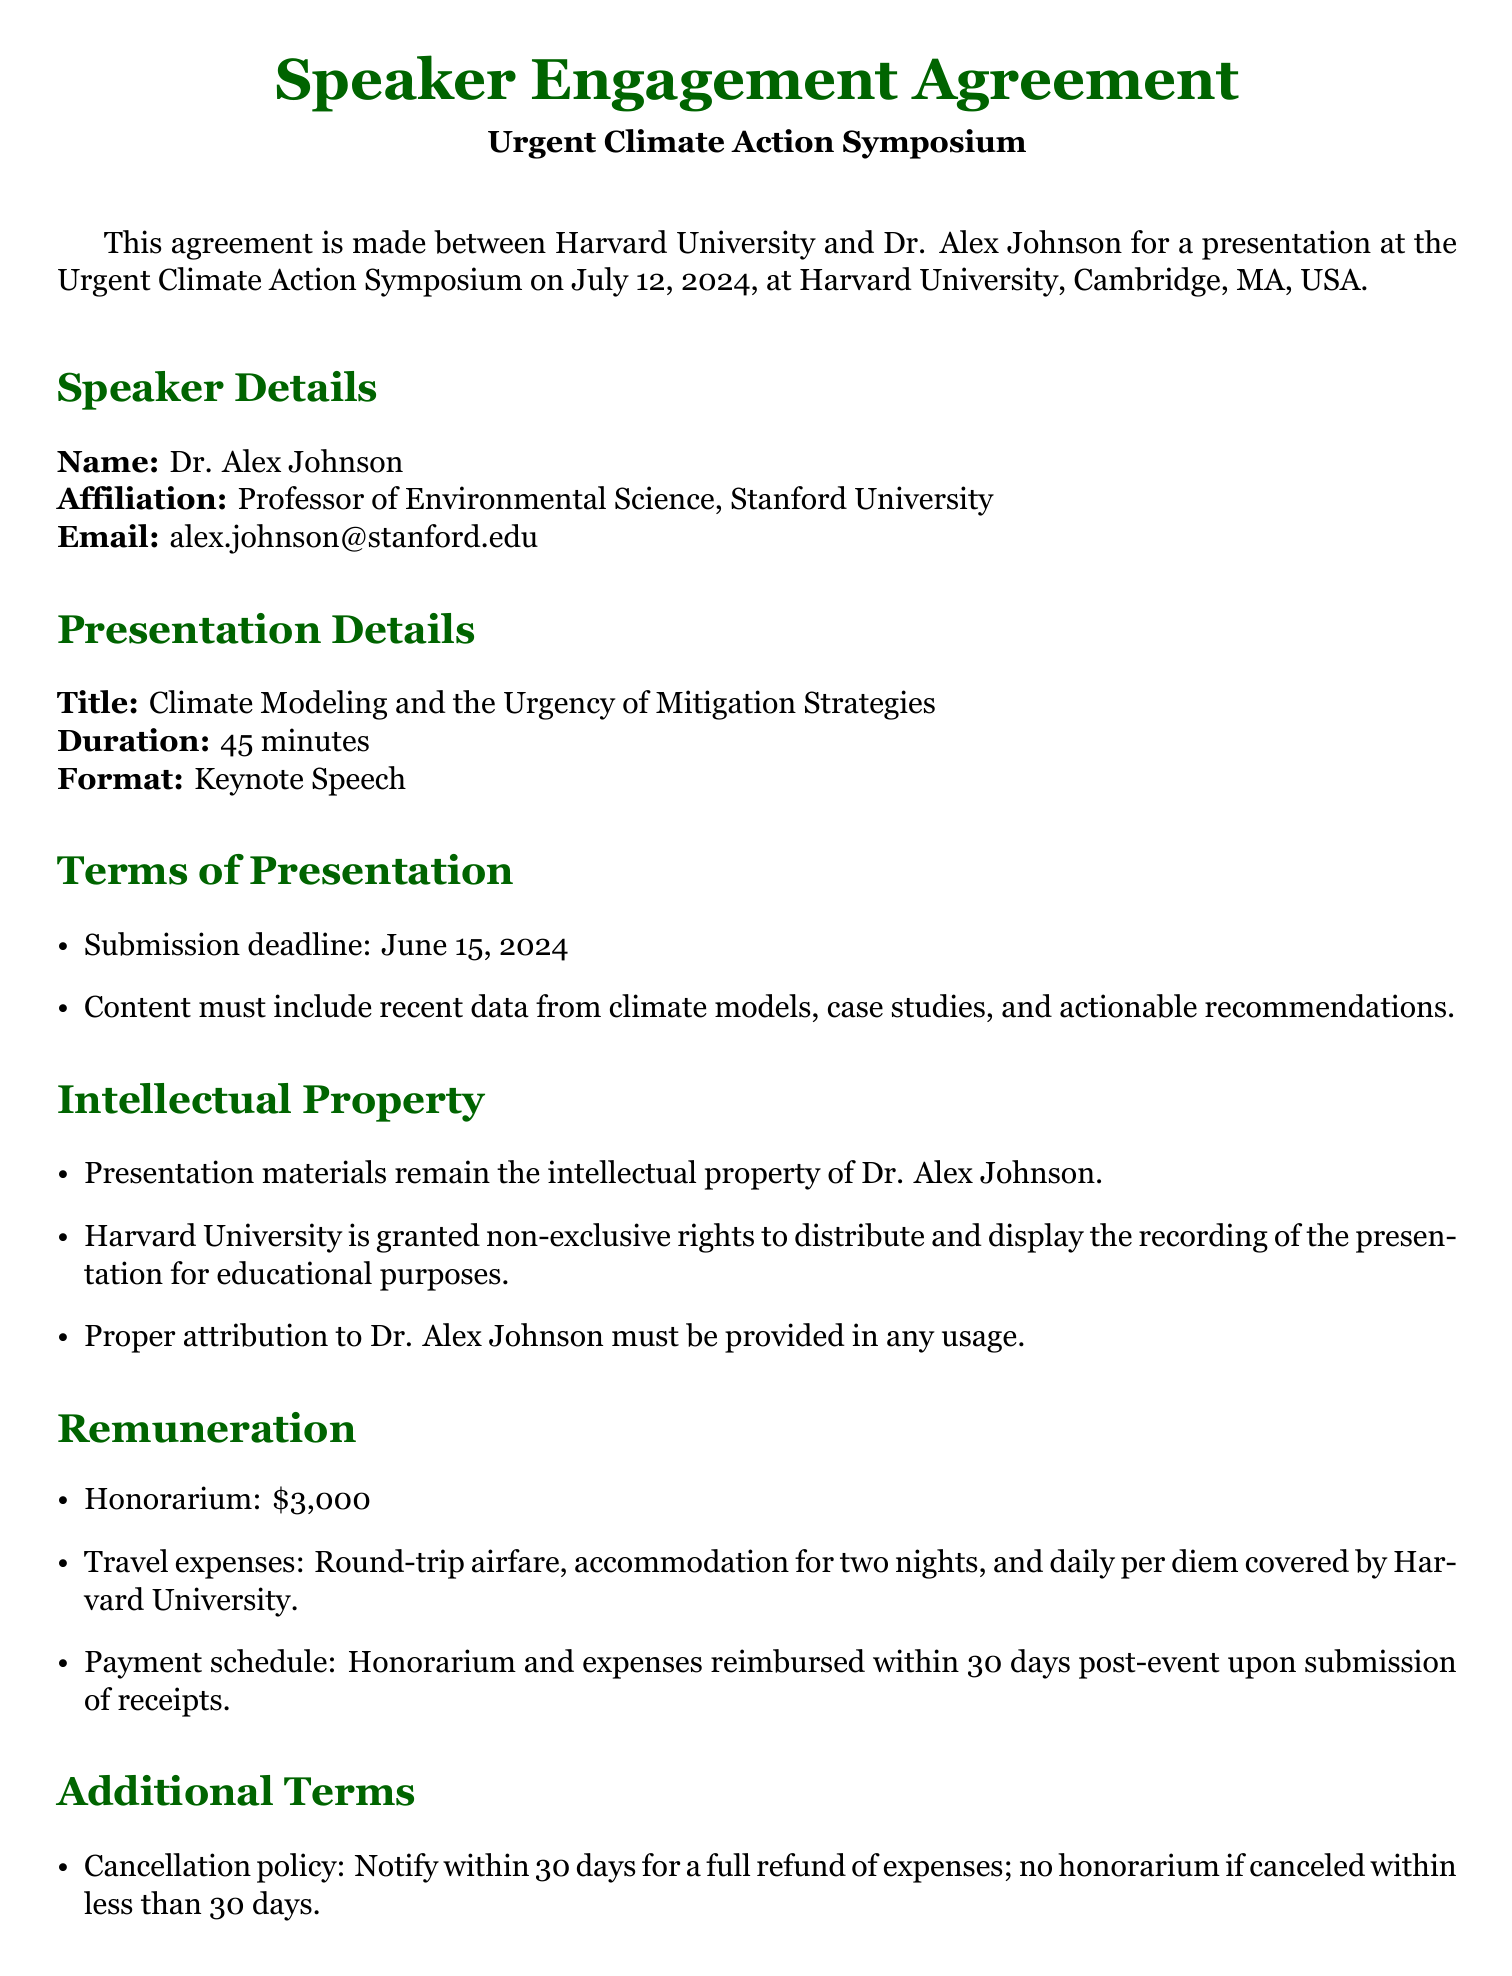What is the name of the speaker? The speaker's name is provided in the document as part of the speaker details section.
Answer: Dr. Alex Johnson What is the title of the presentation? The title of the presentation is specified under the presentation details section.
Answer: Climate Modeling and the Urgency of Mitigation Strategies What is the date of the symposium? The date of the symposium is mentioned at the beginning of the document.
Answer: July 12, 2024 What is the honorarium amount? The honorarium amount is detailed under the remuneration section of the agreement.
Answer: $3,000 What is the submission deadline for the presentation content? The submission deadline is provided in the terms of presentation section.
Answer: June 15, 2024 What should Dr. Alex Johnson include in the presentation content? This information is specified in the terms of presentation section.
Answer: Recent data from climate models, case studies, and actionable recommendations What are the travel expenses covered? The specific travel expenses covered are outlined in the remuneration section.
Answer: Round-trip airfare, accommodation for two nights, and daily per diem What is the cancellation policy? The cancellation policy is explained in the additional terms section of the document.
Answer: Notify within 30 days for a full refund of expenses What rights does Harvard University have regarding the presentation materials? This information is detailed in the intellectual property section of the agreement.
Answer: Non-exclusive rights to distribute and display for educational purposes What happens if the speaker cancels less than 30 days before the event? This information is provided in the additional terms section regarding cancellations.
Answer: No honorarium if canceled within less than 30 days 